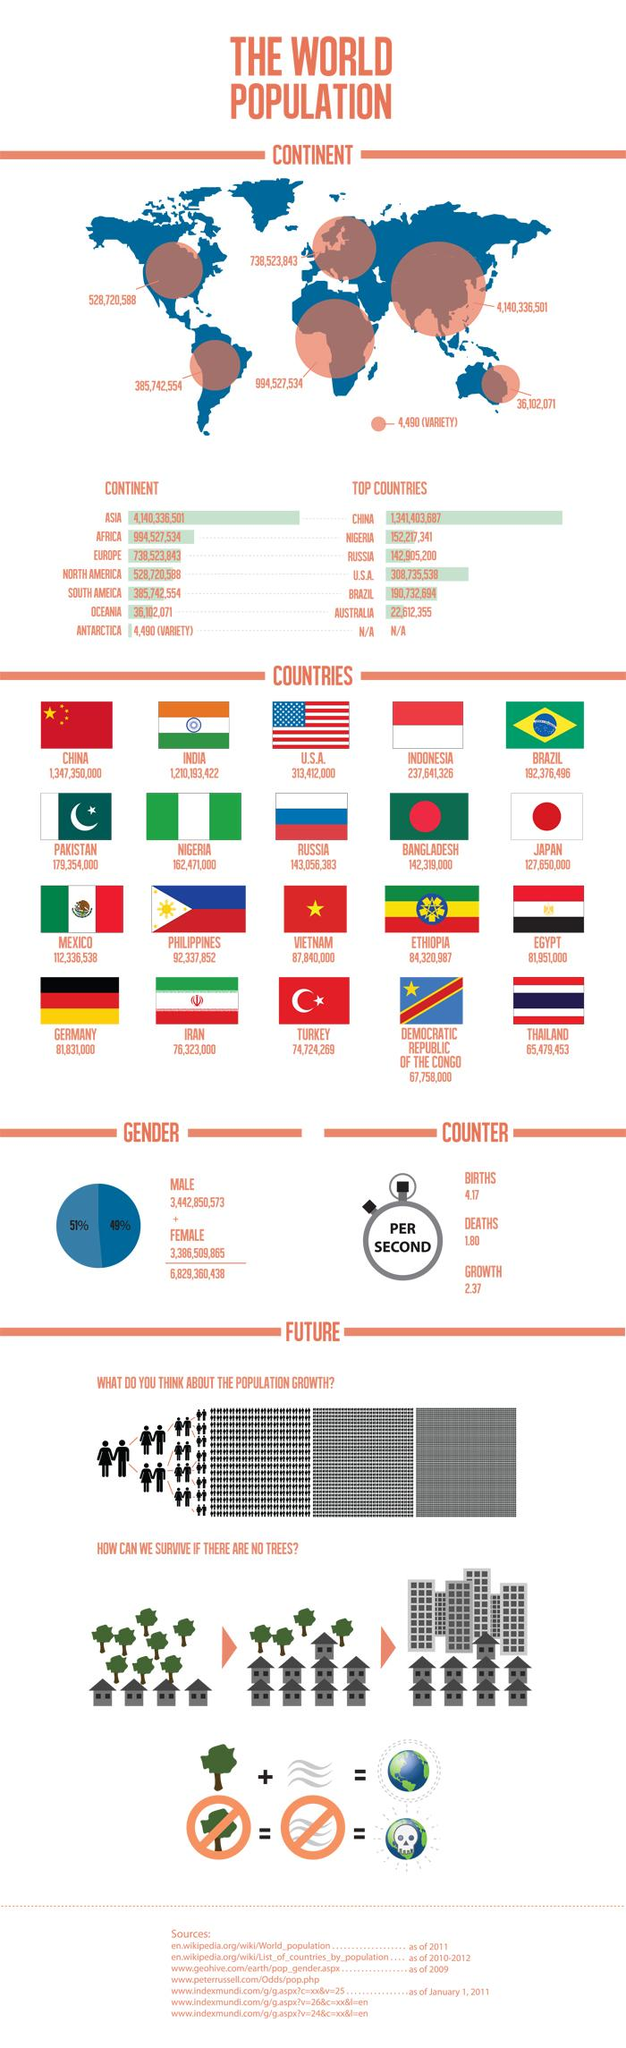Highlight a few significant elements in this photo. As of 2021, the population in Thailand is approximately 65,479,453 people. The population in Russia is 143,056,383. The population in Iran is approximately 76,323,000. According to recent data, the population in Indonesia is approximately 237,641,326. The combined number of births and deaths per second is 5.97... 